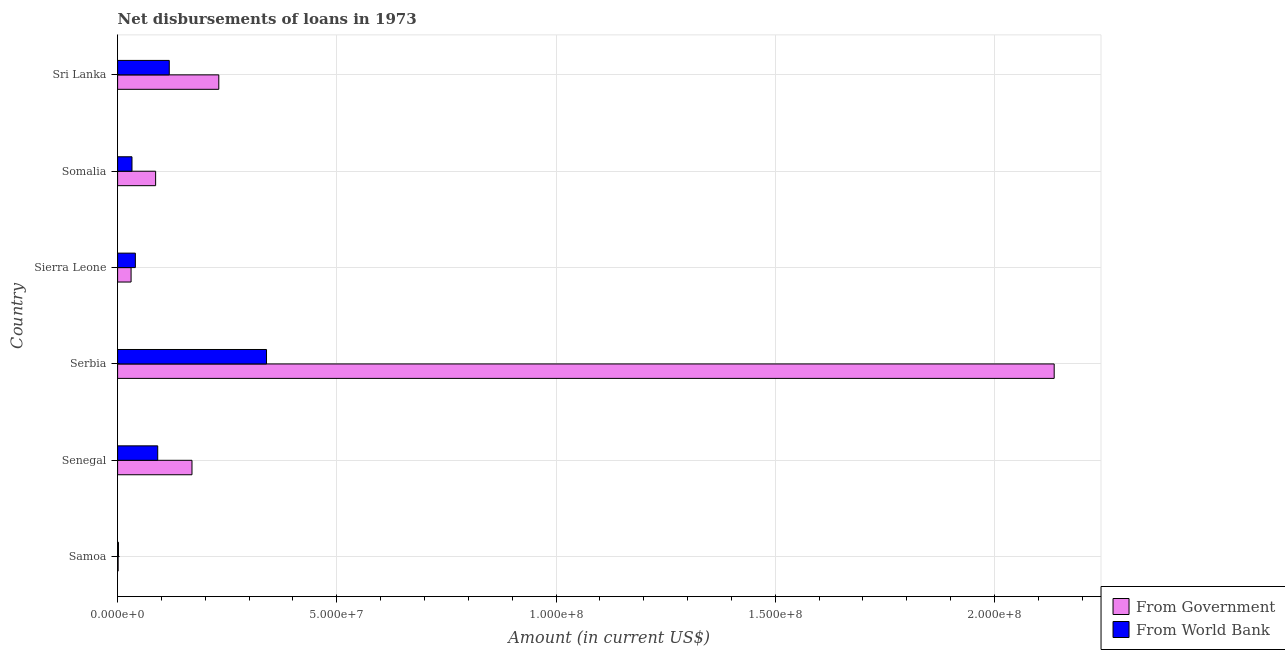How many different coloured bars are there?
Your answer should be very brief. 2. Are the number of bars on each tick of the Y-axis equal?
Your response must be concise. Yes. What is the label of the 1st group of bars from the top?
Provide a succinct answer. Sri Lanka. What is the net disbursements of loan from world bank in Sri Lanka?
Offer a terse response. 1.18e+07. Across all countries, what is the maximum net disbursements of loan from world bank?
Your answer should be compact. 3.40e+07. Across all countries, what is the minimum net disbursements of loan from government?
Your answer should be compact. 1.23e+05. In which country was the net disbursements of loan from government maximum?
Offer a terse response. Serbia. In which country was the net disbursements of loan from government minimum?
Give a very brief answer. Samoa. What is the total net disbursements of loan from government in the graph?
Provide a short and direct response. 2.66e+08. What is the difference between the net disbursements of loan from world bank in Samoa and that in Somalia?
Offer a terse response. -3.08e+06. What is the difference between the net disbursements of loan from government in Serbia and the net disbursements of loan from world bank in Sierra Leone?
Provide a short and direct response. 2.10e+08. What is the average net disbursements of loan from world bank per country?
Offer a very short reply. 1.04e+07. What is the difference between the net disbursements of loan from government and net disbursements of loan from world bank in Senegal?
Your answer should be compact. 7.82e+06. In how many countries, is the net disbursements of loan from government greater than 70000000 US$?
Offer a terse response. 1. What is the ratio of the net disbursements of loan from government in Serbia to that in Sierra Leone?
Your answer should be compact. 69.5. Is the net disbursements of loan from world bank in Sierra Leone less than that in Somalia?
Provide a succinct answer. No. Is the difference between the net disbursements of loan from world bank in Samoa and Sierra Leone greater than the difference between the net disbursements of loan from government in Samoa and Sierra Leone?
Provide a succinct answer. No. What is the difference between the highest and the second highest net disbursements of loan from world bank?
Provide a short and direct response. 2.22e+07. What is the difference between the highest and the lowest net disbursements of loan from world bank?
Your response must be concise. 3.38e+07. In how many countries, is the net disbursements of loan from world bank greater than the average net disbursements of loan from world bank taken over all countries?
Your answer should be very brief. 2. Is the sum of the net disbursements of loan from government in Samoa and Serbia greater than the maximum net disbursements of loan from world bank across all countries?
Offer a terse response. Yes. What does the 1st bar from the top in Sri Lanka represents?
Your answer should be very brief. From World Bank. What does the 2nd bar from the bottom in Sri Lanka represents?
Your answer should be very brief. From World Bank. How many bars are there?
Give a very brief answer. 12. What is the difference between two consecutive major ticks on the X-axis?
Ensure brevity in your answer.  5.00e+07. Are the values on the major ticks of X-axis written in scientific E-notation?
Your answer should be very brief. Yes. How many legend labels are there?
Offer a very short reply. 2. How are the legend labels stacked?
Offer a terse response. Vertical. What is the title of the graph?
Your answer should be very brief. Net disbursements of loans in 1973. Does "Constant 2005 US$" appear as one of the legend labels in the graph?
Give a very brief answer. No. What is the label or title of the X-axis?
Offer a terse response. Amount (in current US$). What is the Amount (in current US$) in From Government in Samoa?
Your answer should be very brief. 1.23e+05. What is the Amount (in current US$) in From World Bank in Samoa?
Ensure brevity in your answer.  1.96e+05. What is the Amount (in current US$) in From Government in Senegal?
Ensure brevity in your answer.  1.70e+07. What is the Amount (in current US$) in From World Bank in Senegal?
Give a very brief answer. 9.15e+06. What is the Amount (in current US$) in From Government in Serbia?
Keep it short and to the point. 2.14e+08. What is the Amount (in current US$) of From World Bank in Serbia?
Keep it short and to the point. 3.40e+07. What is the Amount (in current US$) in From Government in Sierra Leone?
Make the answer very short. 3.07e+06. What is the Amount (in current US$) of From World Bank in Sierra Leone?
Provide a succinct answer. 4.05e+06. What is the Amount (in current US$) of From Government in Somalia?
Provide a succinct answer. 8.67e+06. What is the Amount (in current US$) in From World Bank in Somalia?
Make the answer very short. 3.28e+06. What is the Amount (in current US$) of From Government in Sri Lanka?
Provide a short and direct response. 2.31e+07. What is the Amount (in current US$) in From World Bank in Sri Lanka?
Offer a terse response. 1.18e+07. Across all countries, what is the maximum Amount (in current US$) in From Government?
Provide a succinct answer. 2.14e+08. Across all countries, what is the maximum Amount (in current US$) in From World Bank?
Give a very brief answer. 3.40e+07. Across all countries, what is the minimum Amount (in current US$) of From Government?
Offer a very short reply. 1.23e+05. Across all countries, what is the minimum Amount (in current US$) in From World Bank?
Give a very brief answer. 1.96e+05. What is the total Amount (in current US$) in From Government in the graph?
Ensure brevity in your answer.  2.66e+08. What is the total Amount (in current US$) in From World Bank in the graph?
Offer a terse response. 6.24e+07. What is the difference between the Amount (in current US$) in From Government in Samoa and that in Senegal?
Provide a short and direct response. -1.68e+07. What is the difference between the Amount (in current US$) of From World Bank in Samoa and that in Senegal?
Offer a very short reply. -8.96e+06. What is the difference between the Amount (in current US$) in From Government in Samoa and that in Serbia?
Ensure brevity in your answer.  -2.14e+08. What is the difference between the Amount (in current US$) in From World Bank in Samoa and that in Serbia?
Give a very brief answer. -3.38e+07. What is the difference between the Amount (in current US$) of From Government in Samoa and that in Sierra Leone?
Keep it short and to the point. -2.95e+06. What is the difference between the Amount (in current US$) of From World Bank in Samoa and that in Sierra Leone?
Your answer should be very brief. -3.85e+06. What is the difference between the Amount (in current US$) in From Government in Samoa and that in Somalia?
Give a very brief answer. -8.55e+06. What is the difference between the Amount (in current US$) in From World Bank in Samoa and that in Somalia?
Offer a very short reply. -3.08e+06. What is the difference between the Amount (in current US$) in From Government in Samoa and that in Sri Lanka?
Offer a terse response. -2.30e+07. What is the difference between the Amount (in current US$) of From World Bank in Samoa and that in Sri Lanka?
Your response must be concise. -1.16e+07. What is the difference between the Amount (in current US$) in From Government in Senegal and that in Serbia?
Offer a very short reply. -1.97e+08. What is the difference between the Amount (in current US$) in From World Bank in Senegal and that in Serbia?
Give a very brief answer. -2.48e+07. What is the difference between the Amount (in current US$) of From Government in Senegal and that in Sierra Leone?
Make the answer very short. 1.39e+07. What is the difference between the Amount (in current US$) of From World Bank in Senegal and that in Sierra Leone?
Make the answer very short. 5.10e+06. What is the difference between the Amount (in current US$) in From Government in Senegal and that in Somalia?
Ensure brevity in your answer.  8.29e+06. What is the difference between the Amount (in current US$) in From World Bank in Senegal and that in Somalia?
Offer a terse response. 5.87e+06. What is the difference between the Amount (in current US$) in From Government in Senegal and that in Sri Lanka?
Ensure brevity in your answer.  -6.12e+06. What is the difference between the Amount (in current US$) in From World Bank in Senegal and that in Sri Lanka?
Offer a very short reply. -2.63e+06. What is the difference between the Amount (in current US$) in From Government in Serbia and that in Sierra Leone?
Give a very brief answer. 2.11e+08. What is the difference between the Amount (in current US$) in From World Bank in Serbia and that in Sierra Leone?
Make the answer very short. 2.99e+07. What is the difference between the Amount (in current US$) in From Government in Serbia and that in Somalia?
Provide a short and direct response. 2.05e+08. What is the difference between the Amount (in current US$) in From World Bank in Serbia and that in Somalia?
Your answer should be compact. 3.07e+07. What is the difference between the Amount (in current US$) of From Government in Serbia and that in Sri Lanka?
Your response must be concise. 1.91e+08. What is the difference between the Amount (in current US$) of From World Bank in Serbia and that in Sri Lanka?
Your answer should be very brief. 2.22e+07. What is the difference between the Amount (in current US$) in From Government in Sierra Leone and that in Somalia?
Make the answer very short. -5.60e+06. What is the difference between the Amount (in current US$) of From World Bank in Sierra Leone and that in Somalia?
Ensure brevity in your answer.  7.70e+05. What is the difference between the Amount (in current US$) of From Government in Sierra Leone and that in Sri Lanka?
Provide a short and direct response. -2.00e+07. What is the difference between the Amount (in current US$) in From World Bank in Sierra Leone and that in Sri Lanka?
Your answer should be compact. -7.74e+06. What is the difference between the Amount (in current US$) of From Government in Somalia and that in Sri Lanka?
Your answer should be compact. -1.44e+07. What is the difference between the Amount (in current US$) in From World Bank in Somalia and that in Sri Lanka?
Your answer should be very brief. -8.51e+06. What is the difference between the Amount (in current US$) in From Government in Samoa and the Amount (in current US$) in From World Bank in Senegal?
Offer a terse response. -9.03e+06. What is the difference between the Amount (in current US$) of From Government in Samoa and the Amount (in current US$) of From World Bank in Serbia?
Your answer should be very brief. -3.38e+07. What is the difference between the Amount (in current US$) of From Government in Samoa and the Amount (in current US$) of From World Bank in Sierra Leone?
Your response must be concise. -3.92e+06. What is the difference between the Amount (in current US$) of From Government in Samoa and the Amount (in current US$) of From World Bank in Somalia?
Offer a very short reply. -3.16e+06. What is the difference between the Amount (in current US$) of From Government in Samoa and the Amount (in current US$) of From World Bank in Sri Lanka?
Offer a very short reply. -1.17e+07. What is the difference between the Amount (in current US$) of From Government in Senegal and the Amount (in current US$) of From World Bank in Serbia?
Provide a succinct answer. -1.70e+07. What is the difference between the Amount (in current US$) of From Government in Senegal and the Amount (in current US$) of From World Bank in Sierra Leone?
Give a very brief answer. 1.29e+07. What is the difference between the Amount (in current US$) of From Government in Senegal and the Amount (in current US$) of From World Bank in Somalia?
Your answer should be compact. 1.37e+07. What is the difference between the Amount (in current US$) in From Government in Senegal and the Amount (in current US$) in From World Bank in Sri Lanka?
Your answer should be very brief. 5.18e+06. What is the difference between the Amount (in current US$) in From Government in Serbia and the Amount (in current US$) in From World Bank in Sierra Leone?
Your answer should be very brief. 2.10e+08. What is the difference between the Amount (in current US$) of From Government in Serbia and the Amount (in current US$) of From World Bank in Somalia?
Your answer should be compact. 2.10e+08. What is the difference between the Amount (in current US$) in From Government in Serbia and the Amount (in current US$) in From World Bank in Sri Lanka?
Provide a short and direct response. 2.02e+08. What is the difference between the Amount (in current US$) of From Government in Sierra Leone and the Amount (in current US$) of From World Bank in Somalia?
Provide a succinct answer. -2.04e+05. What is the difference between the Amount (in current US$) of From Government in Sierra Leone and the Amount (in current US$) of From World Bank in Sri Lanka?
Your response must be concise. -8.71e+06. What is the difference between the Amount (in current US$) of From Government in Somalia and the Amount (in current US$) of From World Bank in Sri Lanka?
Give a very brief answer. -3.11e+06. What is the average Amount (in current US$) of From Government per country?
Ensure brevity in your answer.  4.43e+07. What is the average Amount (in current US$) in From World Bank per country?
Ensure brevity in your answer.  1.04e+07. What is the difference between the Amount (in current US$) in From Government and Amount (in current US$) in From World Bank in Samoa?
Give a very brief answer. -7.30e+04. What is the difference between the Amount (in current US$) of From Government and Amount (in current US$) of From World Bank in Senegal?
Make the answer very short. 7.82e+06. What is the difference between the Amount (in current US$) of From Government and Amount (in current US$) of From World Bank in Serbia?
Make the answer very short. 1.80e+08. What is the difference between the Amount (in current US$) in From Government and Amount (in current US$) in From World Bank in Sierra Leone?
Offer a terse response. -9.74e+05. What is the difference between the Amount (in current US$) in From Government and Amount (in current US$) in From World Bank in Somalia?
Provide a succinct answer. 5.40e+06. What is the difference between the Amount (in current US$) of From Government and Amount (in current US$) of From World Bank in Sri Lanka?
Give a very brief answer. 1.13e+07. What is the ratio of the Amount (in current US$) in From Government in Samoa to that in Senegal?
Provide a short and direct response. 0.01. What is the ratio of the Amount (in current US$) in From World Bank in Samoa to that in Senegal?
Make the answer very short. 0.02. What is the ratio of the Amount (in current US$) in From Government in Samoa to that in Serbia?
Ensure brevity in your answer.  0. What is the ratio of the Amount (in current US$) in From World Bank in Samoa to that in Serbia?
Offer a very short reply. 0.01. What is the ratio of the Amount (in current US$) in From World Bank in Samoa to that in Sierra Leone?
Provide a succinct answer. 0.05. What is the ratio of the Amount (in current US$) of From Government in Samoa to that in Somalia?
Make the answer very short. 0.01. What is the ratio of the Amount (in current US$) of From World Bank in Samoa to that in Somalia?
Ensure brevity in your answer.  0.06. What is the ratio of the Amount (in current US$) in From Government in Samoa to that in Sri Lanka?
Provide a succinct answer. 0.01. What is the ratio of the Amount (in current US$) of From World Bank in Samoa to that in Sri Lanka?
Keep it short and to the point. 0.02. What is the ratio of the Amount (in current US$) in From Government in Senegal to that in Serbia?
Ensure brevity in your answer.  0.08. What is the ratio of the Amount (in current US$) in From World Bank in Senegal to that in Serbia?
Your answer should be very brief. 0.27. What is the ratio of the Amount (in current US$) in From Government in Senegal to that in Sierra Leone?
Ensure brevity in your answer.  5.52. What is the ratio of the Amount (in current US$) in From World Bank in Senegal to that in Sierra Leone?
Offer a very short reply. 2.26. What is the ratio of the Amount (in current US$) in From Government in Senegal to that in Somalia?
Make the answer very short. 1.96. What is the ratio of the Amount (in current US$) in From World Bank in Senegal to that in Somalia?
Your answer should be compact. 2.79. What is the ratio of the Amount (in current US$) in From Government in Senegal to that in Sri Lanka?
Ensure brevity in your answer.  0.73. What is the ratio of the Amount (in current US$) of From World Bank in Senegal to that in Sri Lanka?
Provide a short and direct response. 0.78. What is the ratio of the Amount (in current US$) in From Government in Serbia to that in Sierra Leone?
Keep it short and to the point. 69.5. What is the ratio of the Amount (in current US$) in From World Bank in Serbia to that in Sierra Leone?
Make the answer very short. 8.39. What is the ratio of the Amount (in current US$) of From Government in Serbia to that in Somalia?
Offer a very short reply. 24.63. What is the ratio of the Amount (in current US$) in From World Bank in Serbia to that in Somalia?
Provide a succinct answer. 10.36. What is the ratio of the Amount (in current US$) in From Government in Serbia to that in Sri Lanka?
Provide a short and direct response. 9.26. What is the ratio of the Amount (in current US$) in From World Bank in Serbia to that in Sri Lanka?
Your response must be concise. 2.88. What is the ratio of the Amount (in current US$) in From Government in Sierra Leone to that in Somalia?
Make the answer very short. 0.35. What is the ratio of the Amount (in current US$) in From World Bank in Sierra Leone to that in Somalia?
Provide a succinct answer. 1.23. What is the ratio of the Amount (in current US$) of From Government in Sierra Leone to that in Sri Lanka?
Offer a very short reply. 0.13. What is the ratio of the Amount (in current US$) of From World Bank in Sierra Leone to that in Sri Lanka?
Your response must be concise. 0.34. What is the ratio of the Amount (in current US$) of From Government in Somalia to that in Sri Lanka?
Offer a very short reply. 0.38. What is the ratio of the Amount (in current US$) of From World Bank in Somalia to that in Sri Lanka?
Give a very brief answer. 0.28. What is the difference between the highest and the second highest Amount (in current US$) of From Government?
Your answer should be very brief. 1.91e+08. What is the difference between the highest and the second highest Amount (in current US$) in From World Bank?
Your answer should be compact. 2.22e+07. What is the difference between the highest and the lowest Amount (in current US$) in From Government?
Your response must be concise. 2.14e+08. What is the difference between the highest and the lowest Amount (in current US$) in From World Bank?
Offer a very short reply. 3.38e+07. 